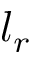<formula> <loc_0><loc_0><loc_500><loc_500>l _ { r }</formula> 